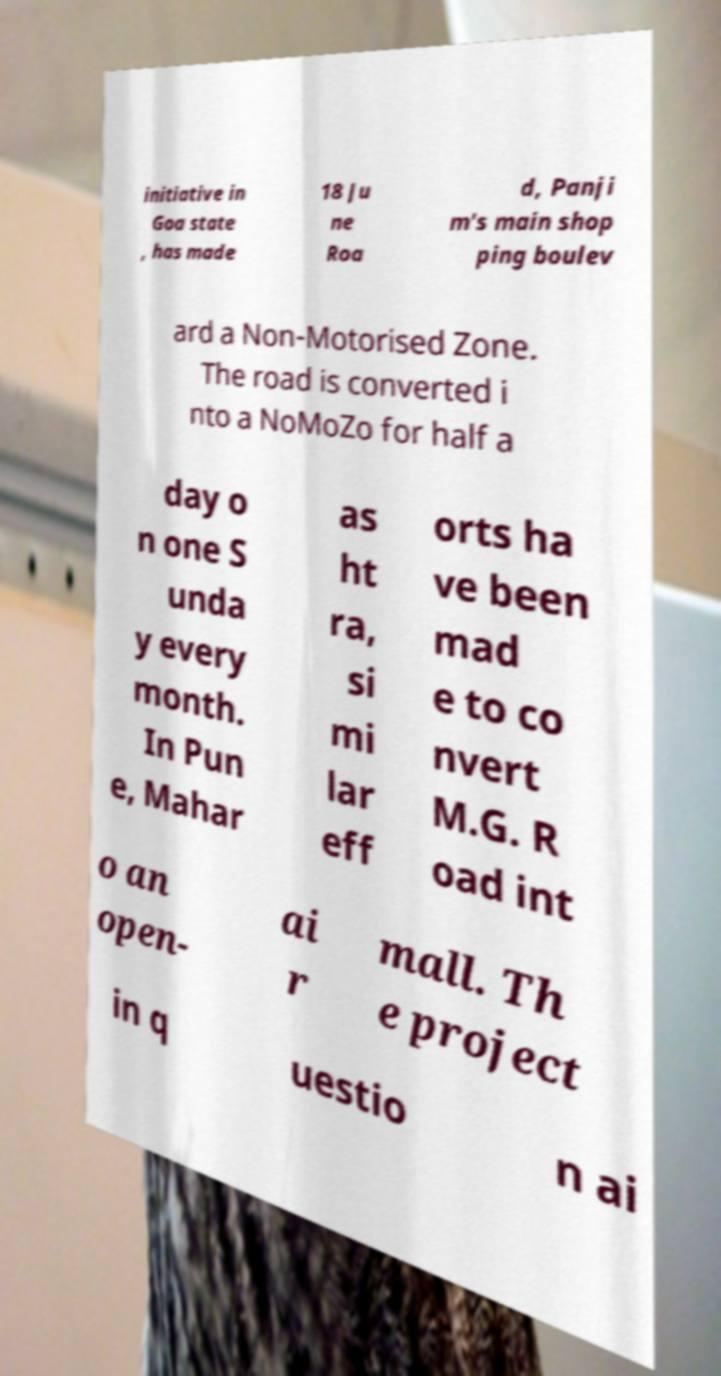For documentation purposes, I need the text within this image transcribed. Could you provide that? initiative in Goa state , has made 18 Ju ne Roa d, Panji m's main shop ping boulev ard a Non-Motorised Zone. The road is converted i nto a NoMoZo for half a day o n one S unda y every month. In Pun e, Mahar as ht ra, si mi lar eff orts ha ve been mad e to co nvert M.G. R oad int o an open- ai r mall. Th e project in q uestio n ai 